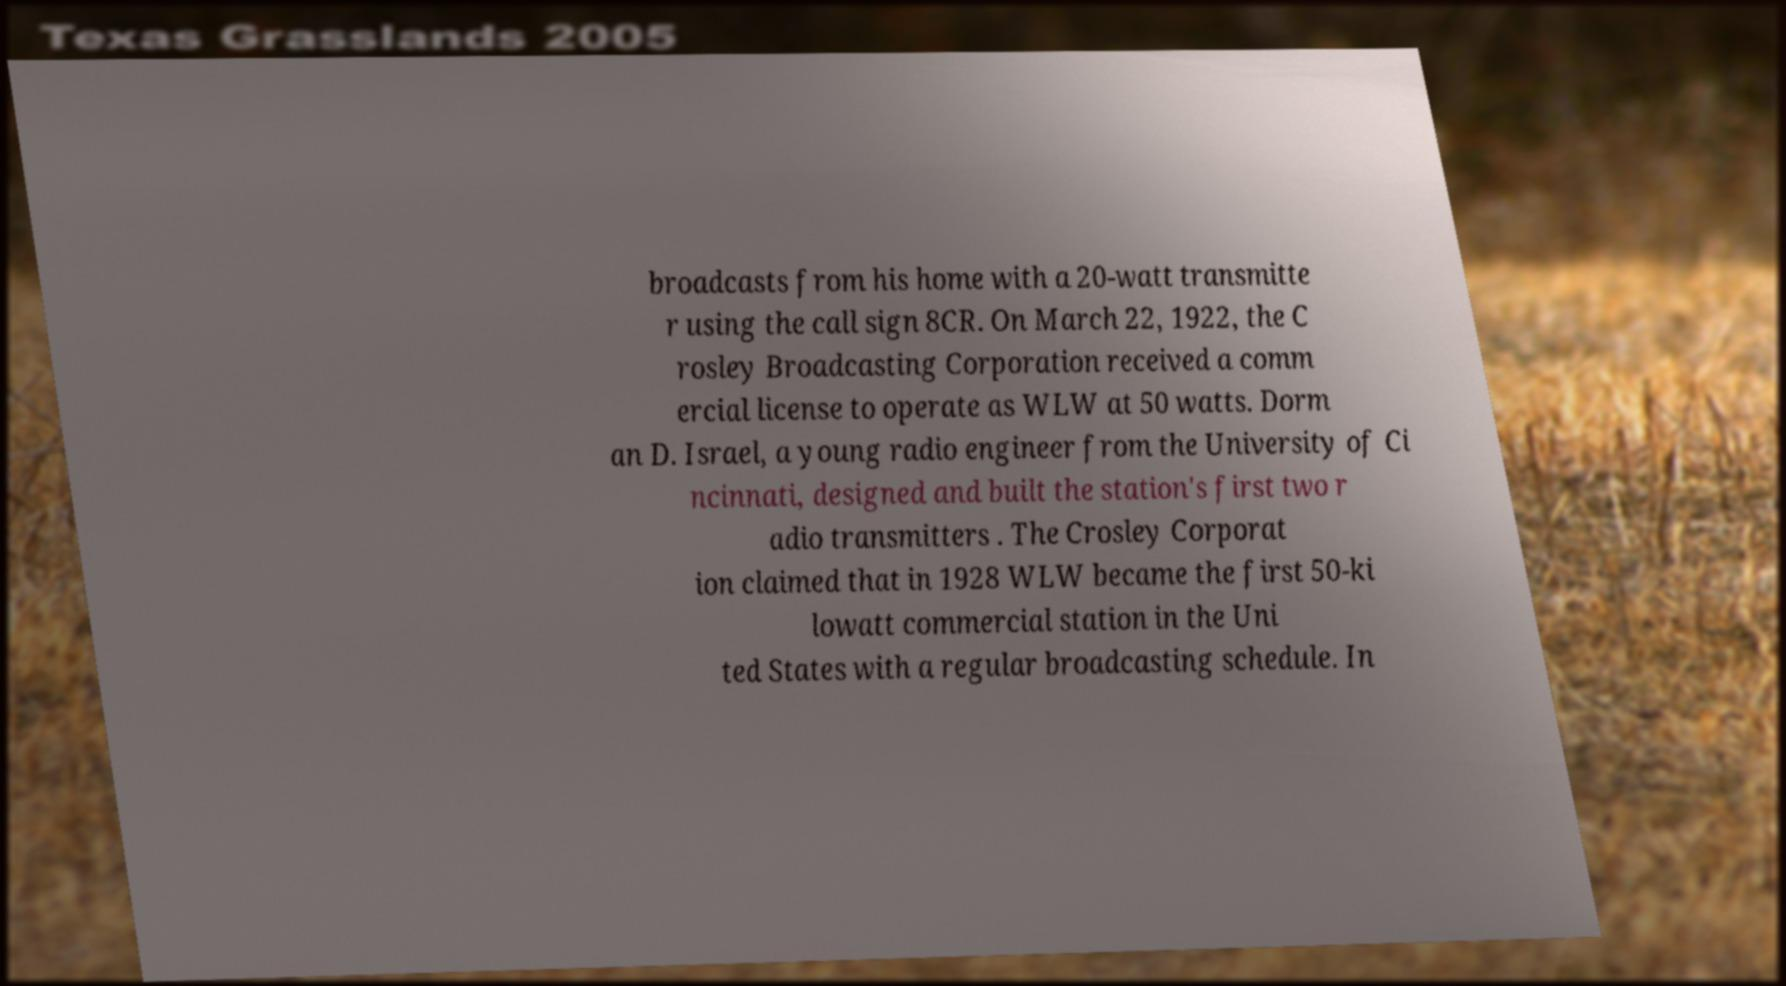For documentation purposes, I need the text within this image transcribed. Could you provide that? broadcasts from his home with a 20-watt transmitte r using the call sign 8CR. On March 22, 1922, the C rosley Broadcasting Corporation received a comm ercial license to operate as WLW at 50 watts. Dorm an D. Israel, a young radio engineer from the University of Ci ncinnati, designed and built the station's first two r adio transmitters . The Crosley Corporat ion claimed that in 1928 WLW became the first 50-ki lowatt commercial station in the Uni ted States with a regular broadcasting schedule. In 